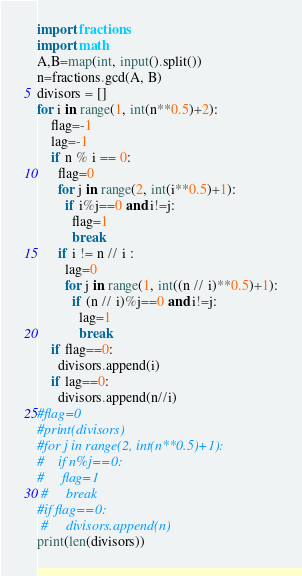Convert code to text. <code><loc_0><loc_0><loc_500><loc_500><_Python_>import fractions
import math
A,B=map(int, input().split())
n=fractions.gcd(A, B)
divisors = []
for i in range(1, int(n**0.5)+2):
    flag=-1
    lag=-1
    if n % i == 0:
      flag=0
      for j in range(2, int(i**0.5)+1):
        if i%j==0 and i!=j:
          flag=1
          break
      if i != n // i :
        lag=0
        for j in range(1, int((n // i)**0.5)+1):
          if (n // i)%j==0 and i!=j:
            lag=1
            break
    if flag==0:
      divisors.append(i)
    if lag==0:
      divisors.append(n//i)
#flag=0
#print(divisors)
#for j in range(2, int(n**0.5)+1):
#    if n%j==0:
#     flag=1
 #     break
#if flag==0:
 #     divisors.append(n)
print(len(divisors))  </code> 